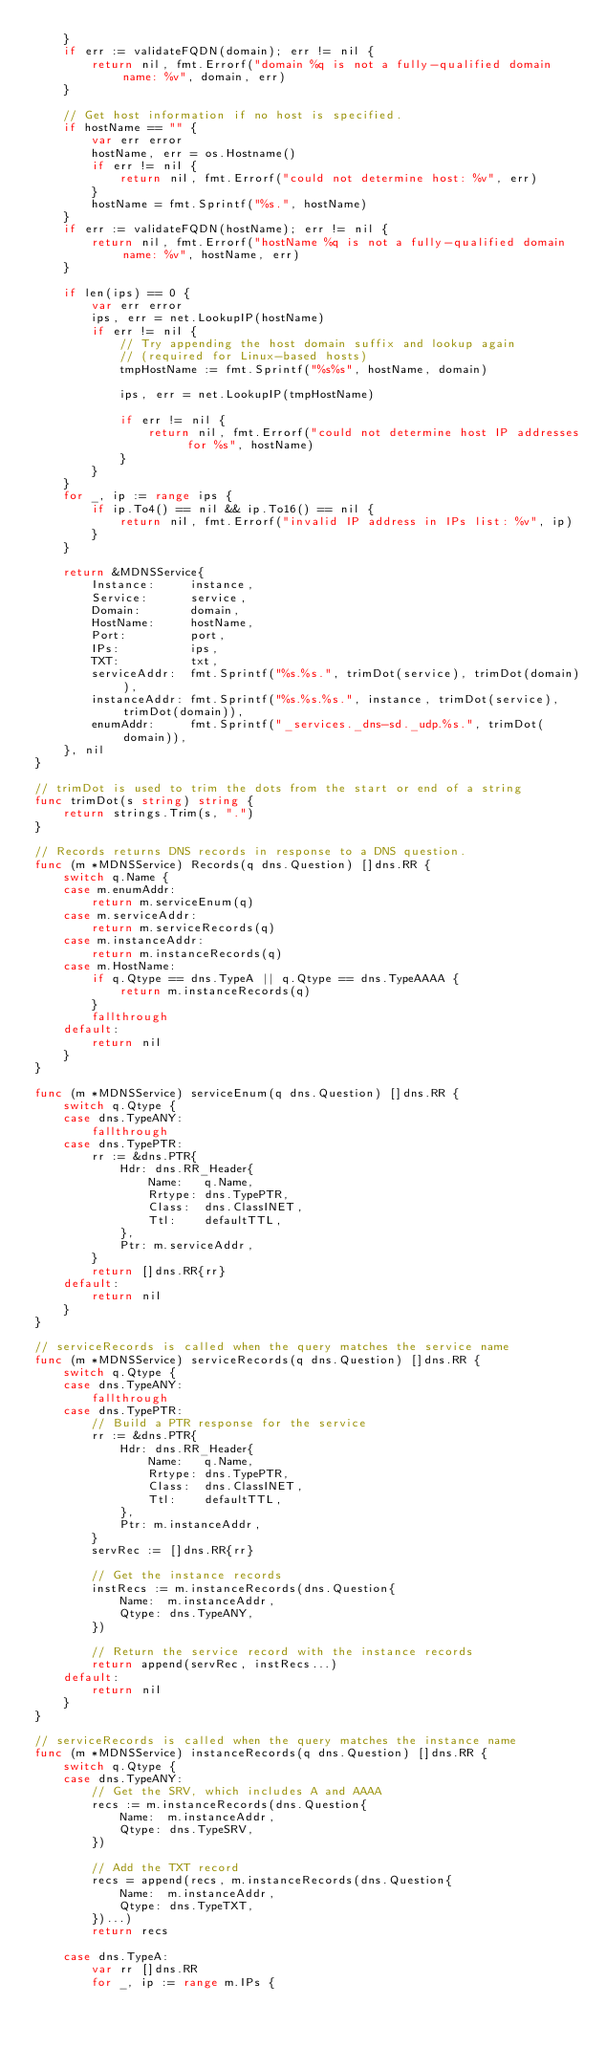Convert code to text. <code><loc_0><loc_0><loc_500><loc_500><_Go_>	}
	if err := validateFQDN(domain); err != nil {
		return nil, fmt.Errorf("domain %q is not a fully-qualified domain name: %v", domain, err)
	}

	// Get host information if no host is specified.
	if hostName == "" {
		var err error
		hostName, err = os.Hostname()
		if err != nil {
			return nil, fmt.Errorf("could not determine host: %v", err)
		}
		hostName = fmt.Sprintf("%s.", hostName)
	}
	if err := validateFQDN(hostName); err != nil {
		return nil, fmt.Errorf("hostName %q is not a fully-qualified domain name: %v", hostName, err)
	}

	if len(ips) == 0 {
		var err error
		ips, err = net.LookupIP(hostName)
		if err != nil {
			// Try appending the host domain suffix and lookup again
			// (required for Linux-based hosts)
			tmpHostName := fmt.Sprintf("%s%s", hostName, domain)

			ips, err = net.LookupIP(tmpHostName)

			if err != nil {
				return nil, fmt.Errorf("could not determine host IP addresses for %s", hostName)
			}
		}
	}
	for _, ip := range ips {
		if ip.To4() == nil && ip.To16() == nil {
			return nil, fmt.Errorf("invalid IP address in IPs list: %v", ip)
		}
	}

	return &MDNSService{
		Instance:     instance,
		Service:      service,
		Domain:       domain,
		HostName:     hostName,
		Port:         port,
		IPs:          ips,
		TXT:          txt,
		serviceAddr:  fmt.Sprintf("%s.%s.", trimDot(service), trimDot(domain)),
		instanceAddr: fmt.Sprintf("%s.%s.%s.", instance, trimDot(service), trimDot(domain)),
		enumAddr:     fmt.Sprintf("_services._dns-sd._udp.%s.", trimDot(domain)),
	}, nil
}

// trimDot is used to trim the dots from the start or end of a string
func trimDot(s string) string {
	return strings.Trim(s, ".")
}

// Records returns DNS records in response to a DNS question.
func (m *MDNSService) Records(q dns.Question) []dns.RR {
	switch q.Name {
	case m.enumAddr:
		return m.serviceEnum(q)
	case m.serviceAddr:
		return m.serviceRecords(q)
	case m.instanceAddr:
		return m.instanceRecords(q)
	case m.HostName:
		if q.Qtype == dns.TypeA || q.Qtype == dns.TypeAAAA {
			return m.instanceRecords(q)
		}
		fallthrough
	default:
		return nil
	}
}

func (m *MDNSService) serviceEnum(q dns.Question) []dns.RR {
	switch q.Qtype {
	case dns.TypeANY:
		fallthrough
	case dns.TypePTR:
		rr := &dns.PTR{
			Hdr: dns.RR_Header{
				Name:   q.Name,
				Rrtype: dns.TypePTR,
				Class:  dns.ClassINET,
				Ttl:    defaultTTL,
			},
			Ptr: m.serviceAddr,
		}
		return []dns.RR{rr}
	default:
		return nil
	}
}

// serviceRecords is called when the query matches the service name
func (m *MDNSService) serviceRecords(q dns.Question) []dns.RR {
	switch q.Qtype {
	case dns.TypeANY:
		fallthrough
	case dns.TypePTR:
		// Build a PTR response for the service
		rr := &dns.PTR{
			Hdr: dns.RR_Header{
				Name:   q.Name,
				Rrtype: dns.TypePTR,
				Class:  dns.ClassINET,
				Ttl:    defaultTTL,
			},
			Ptr: m.instanceAddr,
		}
		servRec := []dns.RR{rr}

		// Get the instance records
		instRecs := m.instanceRecords(dns.Question{
			Name:  m.instanceAddr,
			Qtype: dns.TypeANY,
		})

		// Return the service record with the instance records
		return append(servRec, instRecs...)
	default:
		return nil
	}
}

// serviceRecords is called when the query matches the instance name
func (m *MDNSService) instanceRecords(q dns.Question) []dns.RR {
	switch q.Qtype {
	case dns.TypeANY:
		// Get the SRV, which includes A and AAAA
		recs := m.instanceRecords(dns.Question{
			Name:  m.instanceAddr,
			Qtype: dns.TypeSRV,
		})

		// Add the TXT record
		recs = append(recs, m.instanceRecords(dns.Question{
			Name:  m.instanceAddr,
			Qtype: dns.TypeTXT,
		})...)
		return recs

	case dns.TypeA:
		var rr []dns.RR
		for _, ip := range m.IPs {</code> 